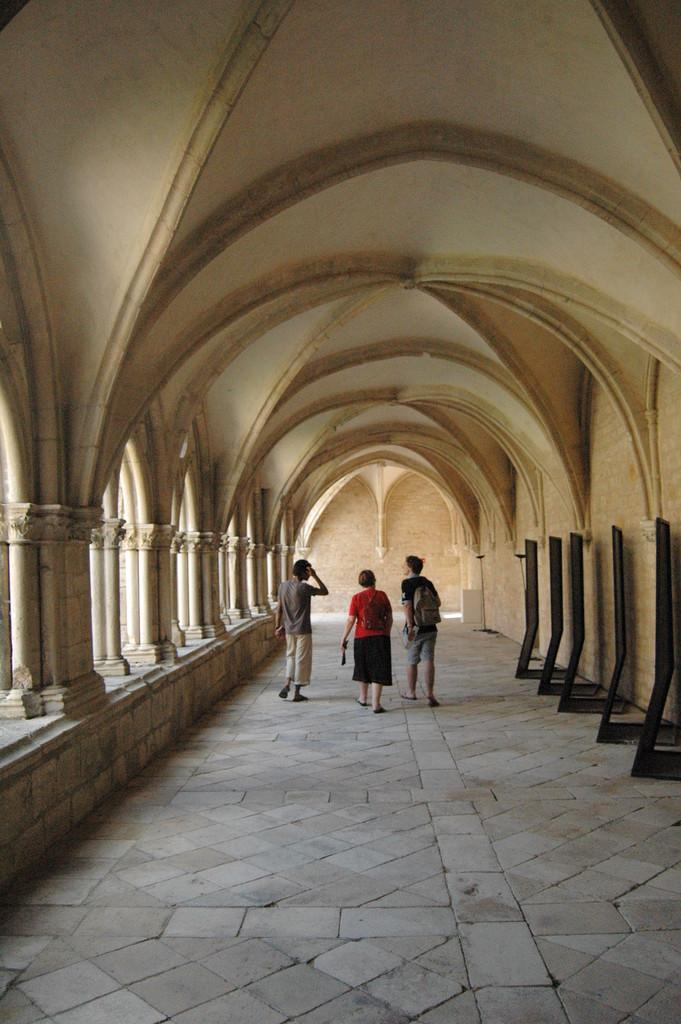What type of location is depicted in the image? The image shows an inside view of a building. How many people can be seen in the image? There are three persons standing in the image. What architectural feature is visible in the image? Pillars are visible in the image. Can you describe any other objects present in the image? There are other objects present in the image, but their specific details are not mentioned in the provided facts. What type of notebook is being used by the person in the image? There is no notebook present in the image. How does the wind affect the people in the image? The image does not depict any wind or its effects on the people. 